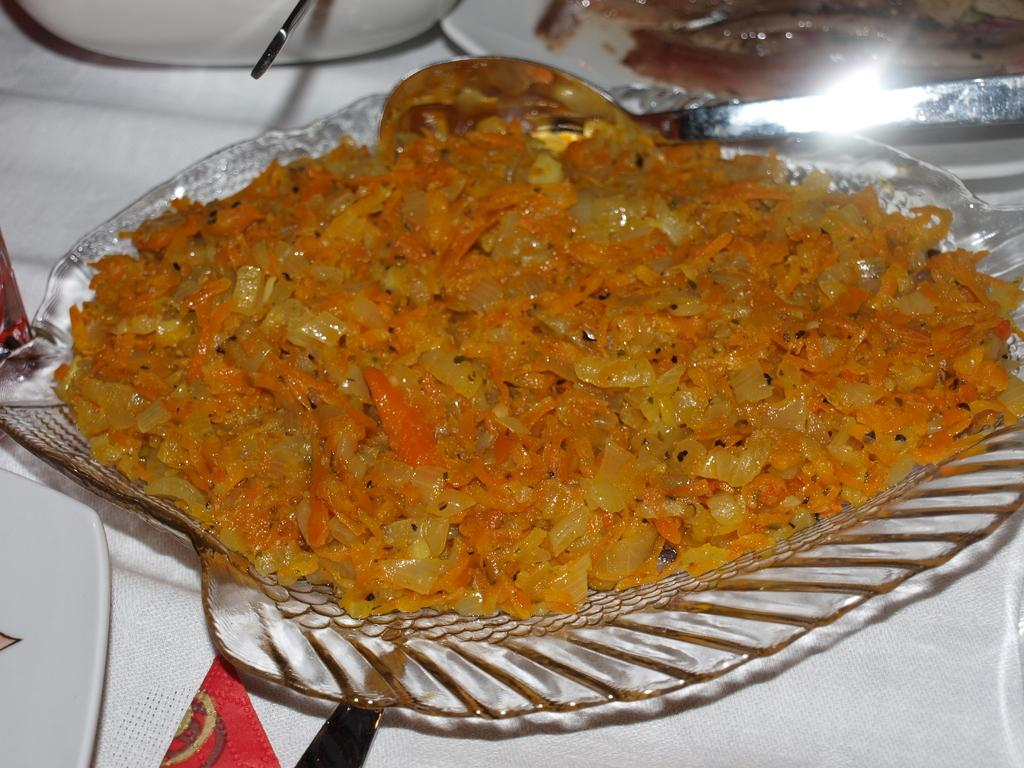What is the material of the plate in the image? The plate in the image is transparent. What is on the plate? There is a food item in the plate. What utensil is visible in the image? There is a spoon in the image. How many women are walking along the coast with a bottle in the image? There are no women, coast, or bottles present in the image. 